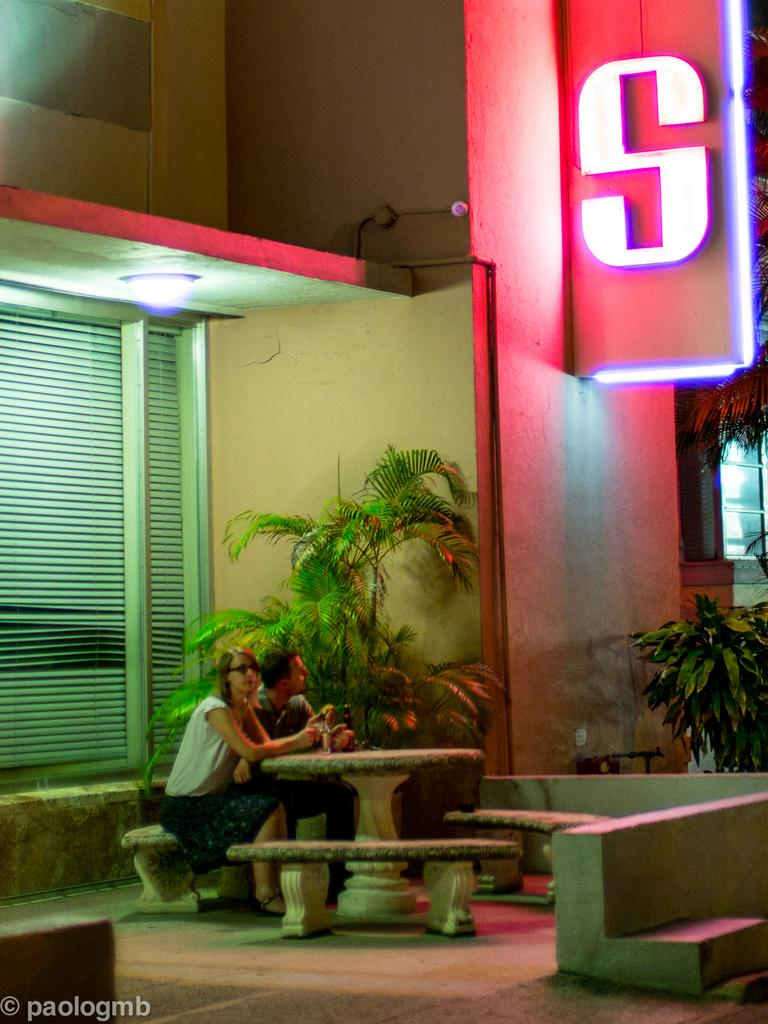How many people are sitting on the bench in the image? There are two persons sitting on a bench in the image. What can be seen in the background of the image? There is a building and plants in the background of the image. Are there any fairies flying around the persons sitting on the bench in the image? There are no fairies present in the image. Is there a store visible in the background of the image? There is no store visible in the image; only a building and plants are present in the background. 